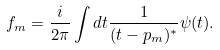Convert formula to latex. <formula><loc_0><loc_0><loc_500><loc_500>f _ { m } = \frac { i } { 2 \pi } \int d t \frac { 1 } { ( t - p _ { m } ) ^ { * } } \psi ( t ) .</formula> 